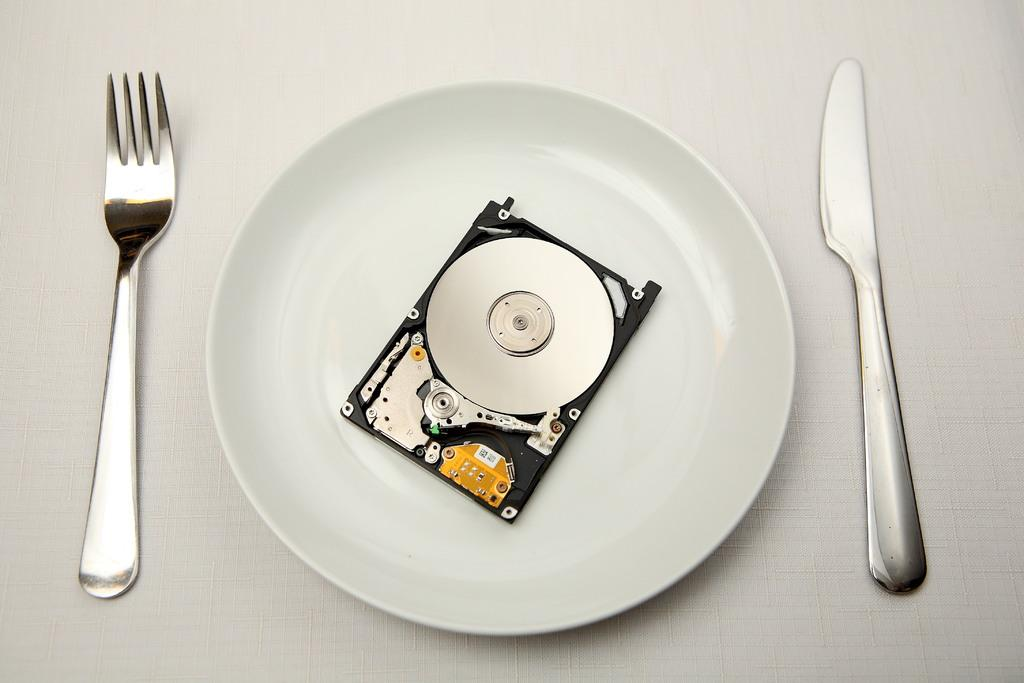What can be seen on the plate in the image? There is an object on the plate in the image. What utensils are visible in the image? There is a fork on the left side of the image and a knife on the right side of the image. What type of pest can be seen crawling on the plate in the image? There is no pest visible on the plate in the image. 